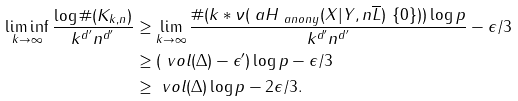<formula> <loc_0><loc_0><loc_500><loc_500>\liminf _ { k \to \infty } \frac { \log \# ( K _ { k , n } ) } { k ^ { d ^ { \prime } } n ^ { d ^ { \prime } } } & \geq \lim _ { k \to \infty } \frac { \# ( k \ast \nu ( \ a H _ { \ a n o n y } ( X | Y , n \overline { L } ) \ \{ 0 \} ) ) \log p } { k ^ { d ^ { \prime } } n ^ { d ^ { \prime } } } - \epsilon / 3 \\ & \geq ( \ v o l ( \Delta ) - \epsilon ^ { \prime } ) \log p - \epsilon / 3 \\ & \geq \ v o l ( \Delta ) \log p - 2 \epsilon / 3 .</formula> 